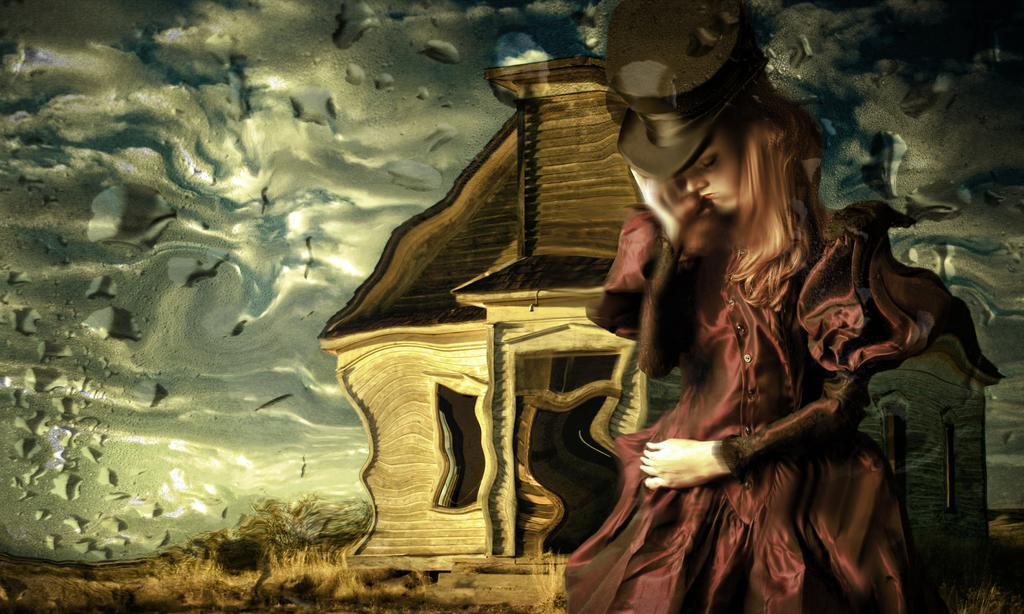What style is the image presented in? The image is a cartoon. Who are the characters in the image? There are women in the image. What type of structure is present in the image? There is a house in the image. What type of natural environment is visible in the image? There are trees and grass in the image. What type of card is being used to improve the acoustics in the house in the image? There is no card or mention of acoustics in the image; it features a cartoon with women, a house, trees, and grass. 